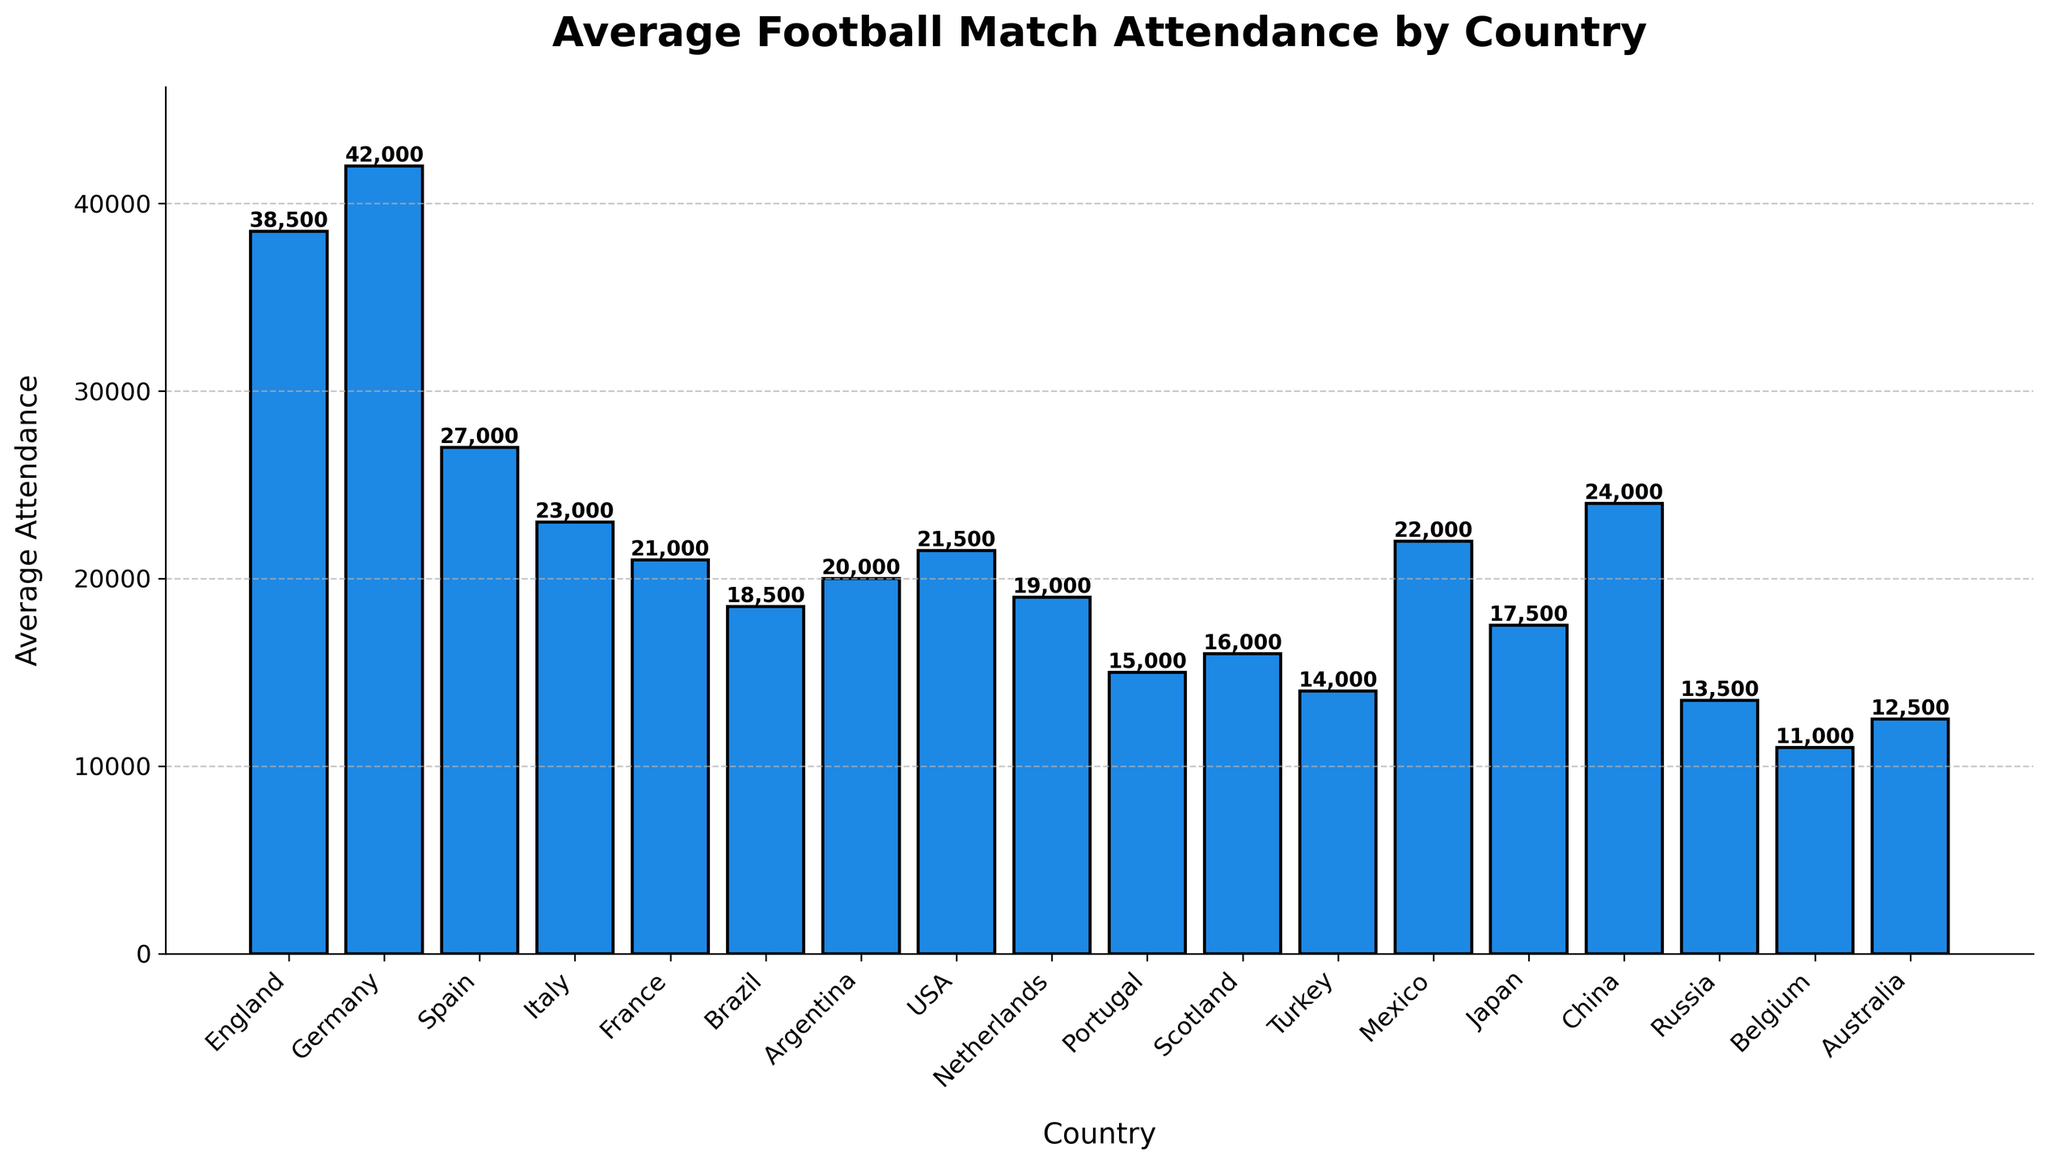Which country has the highest average football match attendance? The bar with the highest height represents the country with the highest average attendance. From the chart, Germany has the highest average attendance at 42,000.
Answer: Germany Which country has the lowest average football match attendance? The bar with the lowest height represents the country with the lowest average attendance. According to the chart, Belgium has the lowest average attendance at 11,000.
Answer: Belgium How much higher is Germany's average attendance compared to England's? From the chart, Germany's average attendance is 42,000 and England's is 38,500. The difference is calculated as 42,000 - 38,500 = 3,500.
Answer: 3,500 What are the average attendances of countries in South America shown in the chart? The South American countries on the chart are Brazil (18,500) and Argentina (20,000). The average attendances are 18,500 and 20,000 respectively.
Answer: 18,500 and 20,000 What is the average attendance for countries with more than 25,000 average attendance? Countries with more than 25,000 average attendance are England (38,500), Germany (42,000), and Spain (27,000). The average of these values is calculated by summing them up and dividing by the number of countries: (38,500 + 42,000 + 27,000)/3 = 107,500/3 ≈ 35,833.
Answer: 35,833 Which continent has the most countries in the chart? To answer this, count the number of countries for each continent. Europe has the most countries: England, Germany, Spain, Italy, France, Netherlands, Portugal, Scotland, Turkey, Russia, Belgium.
Answer: Europe By how much does the average attendance in Spain exceed that in Italy? From the chart, Spain's average attendance is 27,000 and Italy's is 23,000. The difference is 27,000 - 23,000 = 4,000.
Answer: 4,000 If we combine the average attendances of Brazil and Argentina, what is the total? Brazil's average attendance is 18,500 and Argentina's is 20,000. The sum of these is 18,500 + 20,000 = 38,500.
Answer: 38,500 What is the rank of the USA in terms of average football match attendance? To find the rank, sort the countries by their average attendance. USA’s average of 21,500 ranks it after Germany, England, Spain, China, Italy, France, and Mexico, making it 8th.
Answer: 8th How does the average attendance in China compare to that in Mexico? From the chart, China's average attendance is 24,000 and Mexico's is 22,000. Thus, China's attendance is higher than Mexico's.
Answer: China is higher 